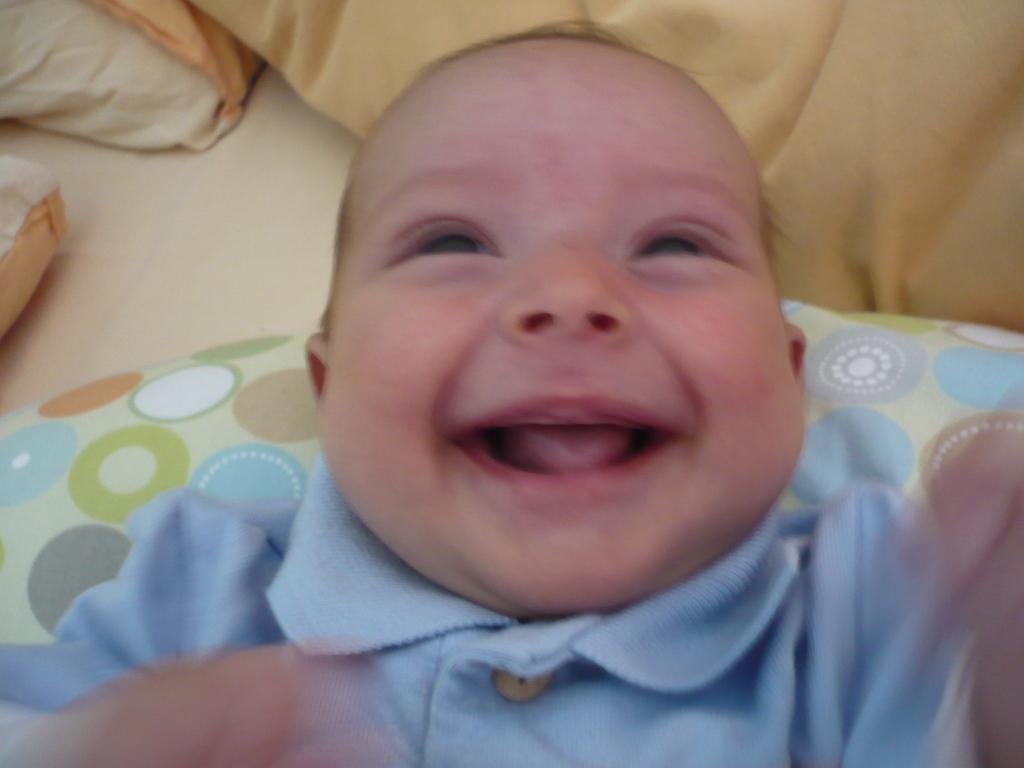What is the main subject of the image? The main subject of the image is a baby. What is the baby doing in the image? The baby is lying down and smiling. What is the baby lying on in the image? The baby is lying on a bed. Are there any additional items visible in the image? Yes, there are pillows in the image. Can you see a tiger playing with the baby in the image? No, there is no tiger present in the image. How many women are visible in the image? There are no women visible in the image; it features a baby lying on a bed with pillows. 